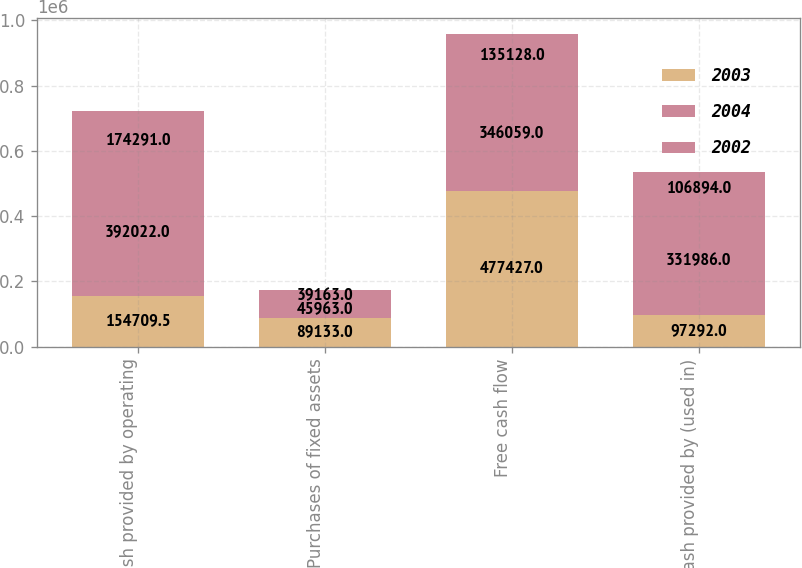<chart> <loc_0><loc_0><loc_500><loc_500><stacked_bar_chart><ecel><fcel>Net cash provided by operating<fcel>Purchases of fixed assets<fcel>Free cash flow<fcel>Net cash provided by (used in)<nl><fcel>2003<fcel>154710<fcel>89133<fcel>477427<fcel>97292<nl><fcel>2004<fcel>392022<fcel>45963<fcel>346059<fcel>331986<nl><fcel>2002<fcel>174291<fcel>39163<fcel>135128<fcel>106894<nl></chart> 